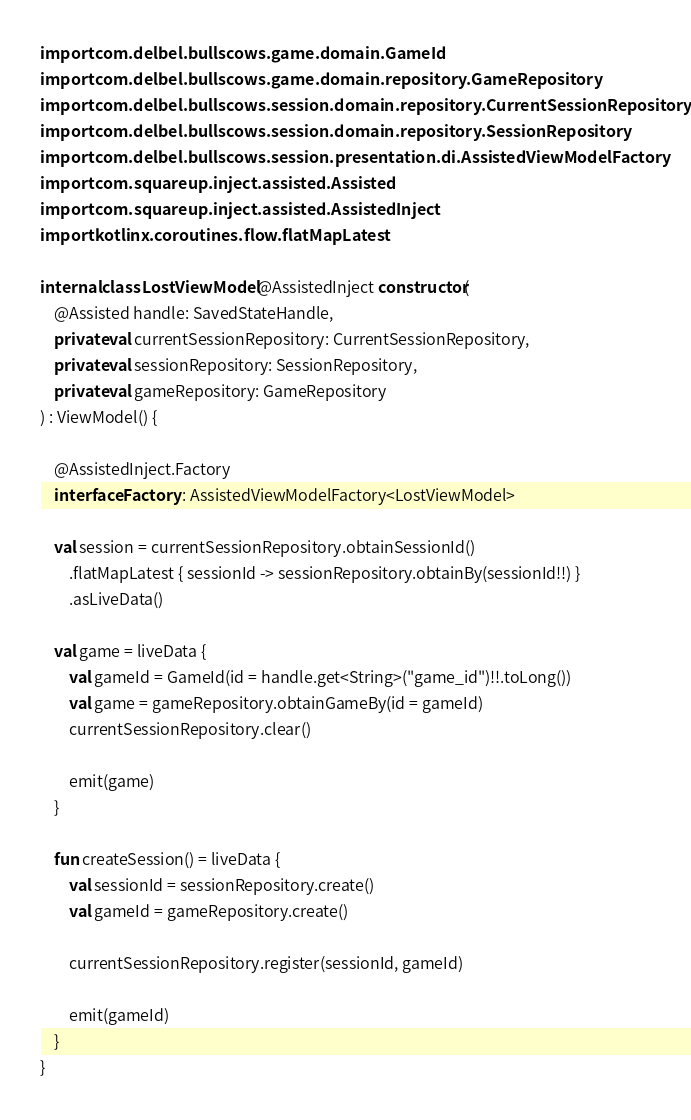<code> <loc_0><loc_0><loc_500><loc_500><_Kotlin_>import com.delbel.bullscows.game.domain.GameId
import com.delbel.bullscows.game.domain.repository.GameRepository
import com.delbel.bullscows.session.domain.repository.CurrentSessionRepository
import com.delbel.bullscows.session.domain.repository.SessionRepository
import com.delbel.bullscows.session.presentation.di.AssistedViewModelFactory
import com.squareup.inject.assisted.Assisted
import com.squareup.inject.assisted.AssistedInject
import kotlinx.coroutines.flow.flatMapLatest

internal class LostViewModel @AssistedInject constructor(
    @Assisted handle: SavedStateHandle,
    private val currentSessionRepository: CurrentSessionRepository,
    private val sessionRepository: SessionRepository,
    private val gameRepository: GameRepository
) : ViewModel() {

    @AssistedInject.Factory
    interface Factory : AssistedViewModelFactory<LostViewModel>

    val session = currentSessionRepository.obtainSessionId()
        .flatMapLatest { sessionId -> sessionRepository.obtainBy(sessionId!!) }
        .asLiveData()

    val game = liveData {
        val gameId = GameId(id = handle.get<String>("game_id")!!.toLong())
        val game = gameRepository.obtainGameBy(id = gameId)
        currentSessionRepository.clear()

        emit(game)
    }

    fun createSession() = liveData {
        val sessionId = sessionRepository.create()
        val gameId = gameRepository.create()

        currentSessionRepository.register(sessionId, gameId)

        emit(gameId)
    }
}</code> 